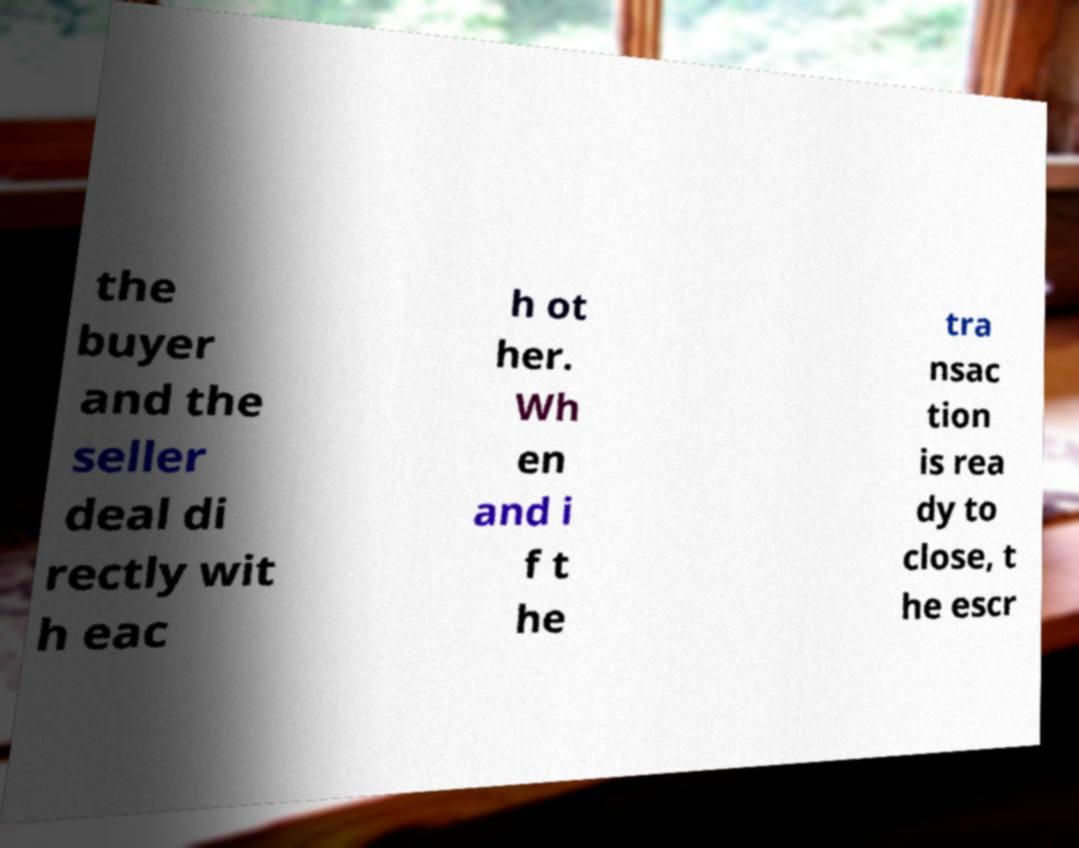Could you assist in decoding the text presented in this image and type it out clearly? the buyer and the seller deal di rectly wit h eac h ot her. Wh en and i f t he tra nsac tion is rea dy to close, t he escr 